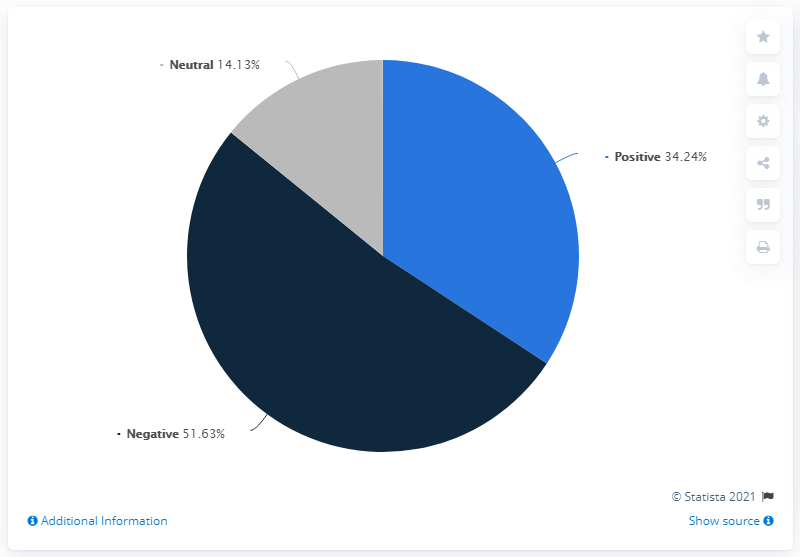Indicate a few pertinent items in this graphic. The leading sentiment is negative. Out of the remaining sentiment apart from negative, 48.37% was observed. 